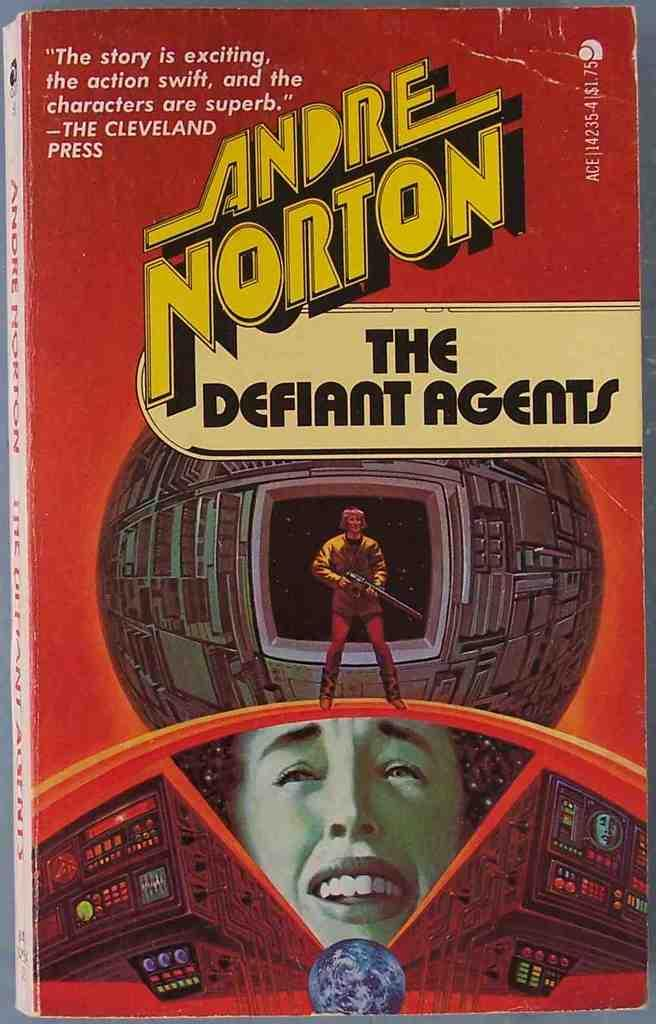<image>
Provide a brief description of the given image. The Defiant Agents written by Andre Norton cost $1.75 